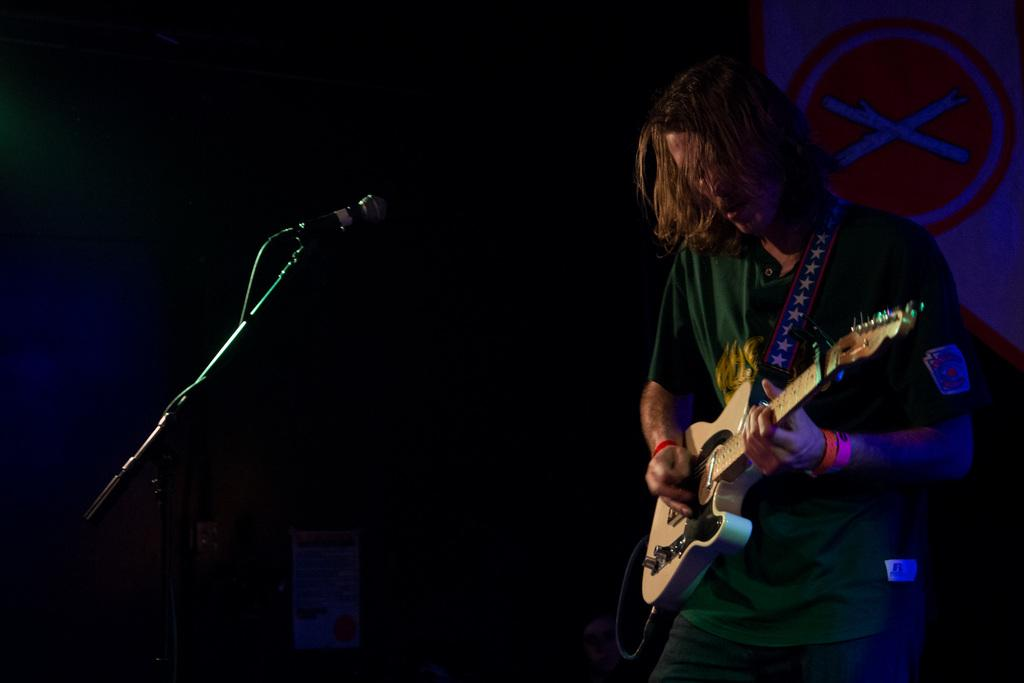What is the man in the image wearing? The man is wearing a green t-shirt and trousers. What is the man doing in the image? The man is playing a guitar. What equipment is present on the left side of the image? There is a microphone and stand on the left side of the image. What can be seen in the background of the image? There is a poster in the background of the image. What type of sweater is the man wearing in the image? The man is not wearing a sweater in the image; he is wearing a green t-shirt and trousers. Can you tell me how many basins are visible in the image? There are no basins present in the image. 